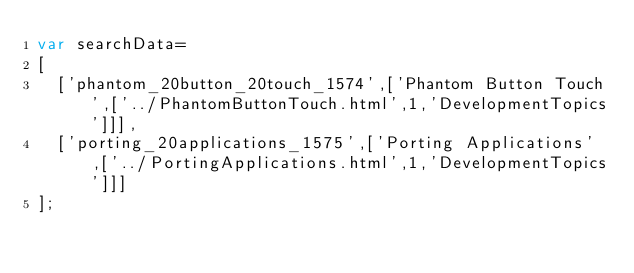Convert code to text. <code><loc_0><loc_0><loc_500><loc_500><_JavaScript_>var searchData=
[
  ['phantom_20button_20touch_1574',['Phantom Button Touch',['../PhantomButtonTouch.html',1,'DevelopmentTopics']]],
  ['porting_20applications_1575',['Porting Applications',['../PortingApplications.html',1,'DevelopmentTopics']]]
];
</code> 